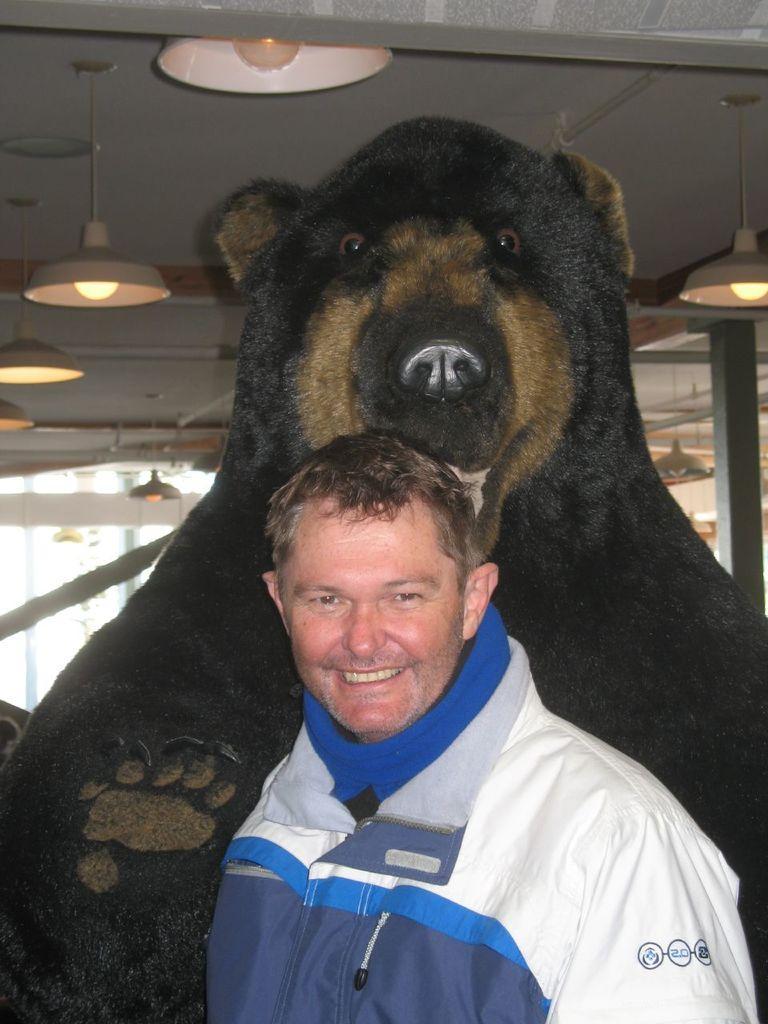How would you summarize this image in a sentence or two? In the image there is a man in the foreground and behind him there is a bear doll, in the background there are lights attached to the roof. 